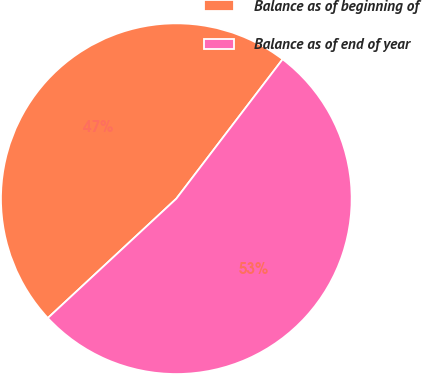<chart> <loc_0><loc_0><loc_500><loc_500><pie_chart><fcel>Balance as of beginning of<fcel>Balance as of end of year<nl><fcel>47.28%<fcel>52.72%<nl></chart> 